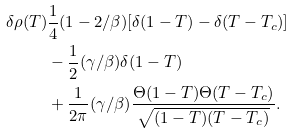<formula> <loc_0><loc_0><loc_500><loc_500>\delta \rho ( T ) & \frac { 1 } { 4 } ( 1 - 2 / \beta ) [ \delta ( 1 - T ) - \delta ( T - T _ { c } ) ] \\ & - \frac { 1 } { 2 } ( \gamma / \beta ) \delta ( 1 - T ) \\ & + \frac { 1 } { 2 \pi } ( \gamma / \beta ) \frac { \Theta ( 1 - T ) \Theta ( T - T _ { c } ) } { \sqrt { ( 1 - T ) ( T - T _ { c } ) } } .</formula> 